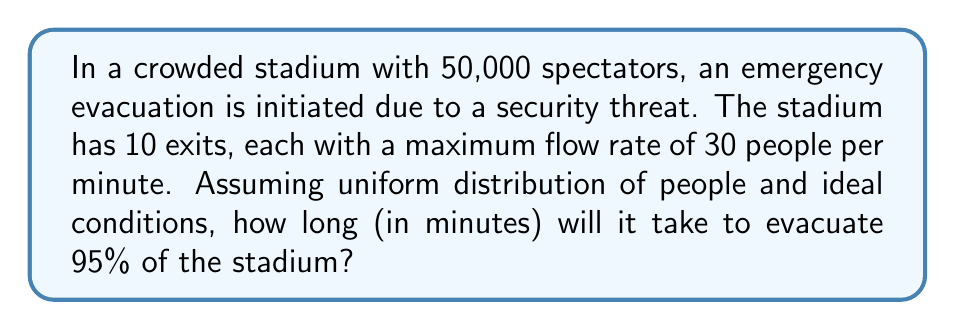What is the answer to this math problem? Let's approach this step-by-step:

1) First, we need to calculate 95% of the total number of spectators:
   $$ 0.95 \times 50,000 = 47,500 \text{ people} $$

2) Now, we need to calculate the total flow rate of all exits combined:
   $$ 10 \text{ exits} \times 30 \text{ people/minute} = 300 \text{ people/minute} $$

3) To find the time needed, we divide the number of people to be evacuated by the total flow rate:
   $$ T = \frac{\text{Number of people}}{\text{Total flow rate}} $$
   $$ T = \frac{47,500}{300} = 158.33 \text{ minutes} $$

4) Since we can't have a fractional minute in this context, we round up to the nearest whole minute:
   $$ T = 159 \text{ minutes} $$

This calculation assumes ideal conditions, which may not be realistic in an actual emergency. Factors such as panic, bottlenecks, and non-uniform distribution of people could significantly increase the evacuation time.
Answer: 159 minutes 